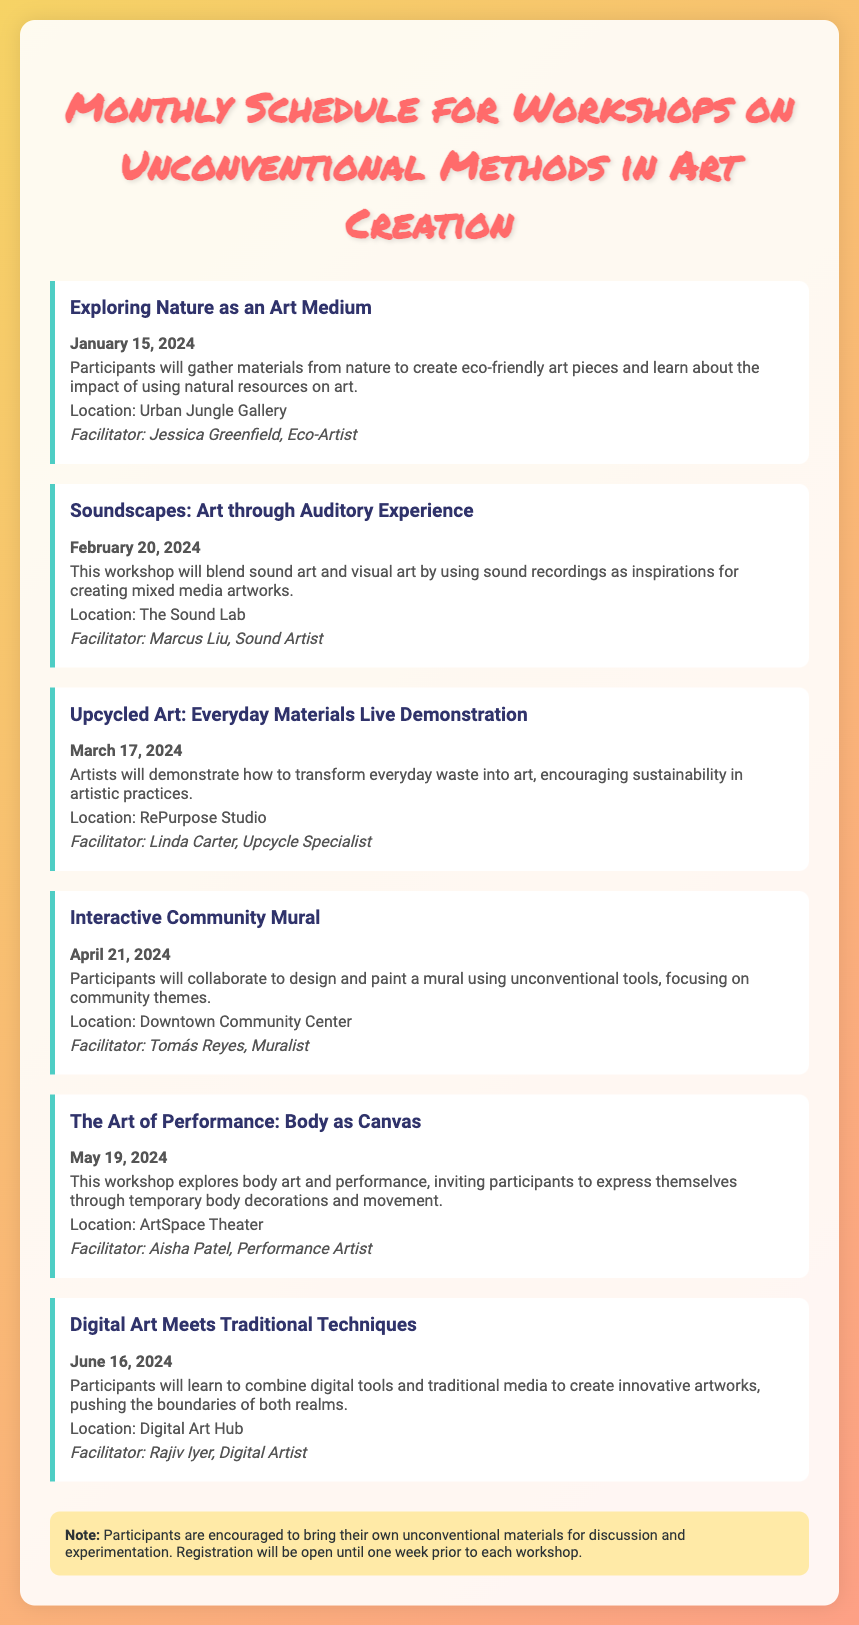what is the title of the first workshop? The title of the first workshop is specified in the document.
Answer: Exploring Nature as an Art Medium when is the workshop on sound art scheduled? The date of the sound art workshop is mentioned under its title.
Answer: February 20, 2024 who is facilitating the workshop on upcycled art? The facilitator's name is provided in the workshop section about upcycled art.
Answer: Linda Carter what is the location for the interactive community mural workshop? The location is clearly stated in the workshop details for the interactive community mural.
Answer: Downtown Community Center how many workshops are scheduled in total? The total number of workshops can be counted from the listed workshops in the document.
Answer: Six which workshop focuses on the body as a canvas? The title of the workshop that highlights the body as a canvas is found in the respective workshop section.
Answer: The Art of Performance: Body as Canvas what type of materials should participants bring? The notes at the end of the document suggest specific items participants should bring.
Answer: Unconventional materials which month features a workshop that combines digital and traditional art techniques? The month for the combined techniques workshop is noted in the respective workshop details.
Answer: June who is the facilitator for the digital art workshop? The facilitator's name is indicated under the digital art workshop description.
Answer: Rajiv Iyer 